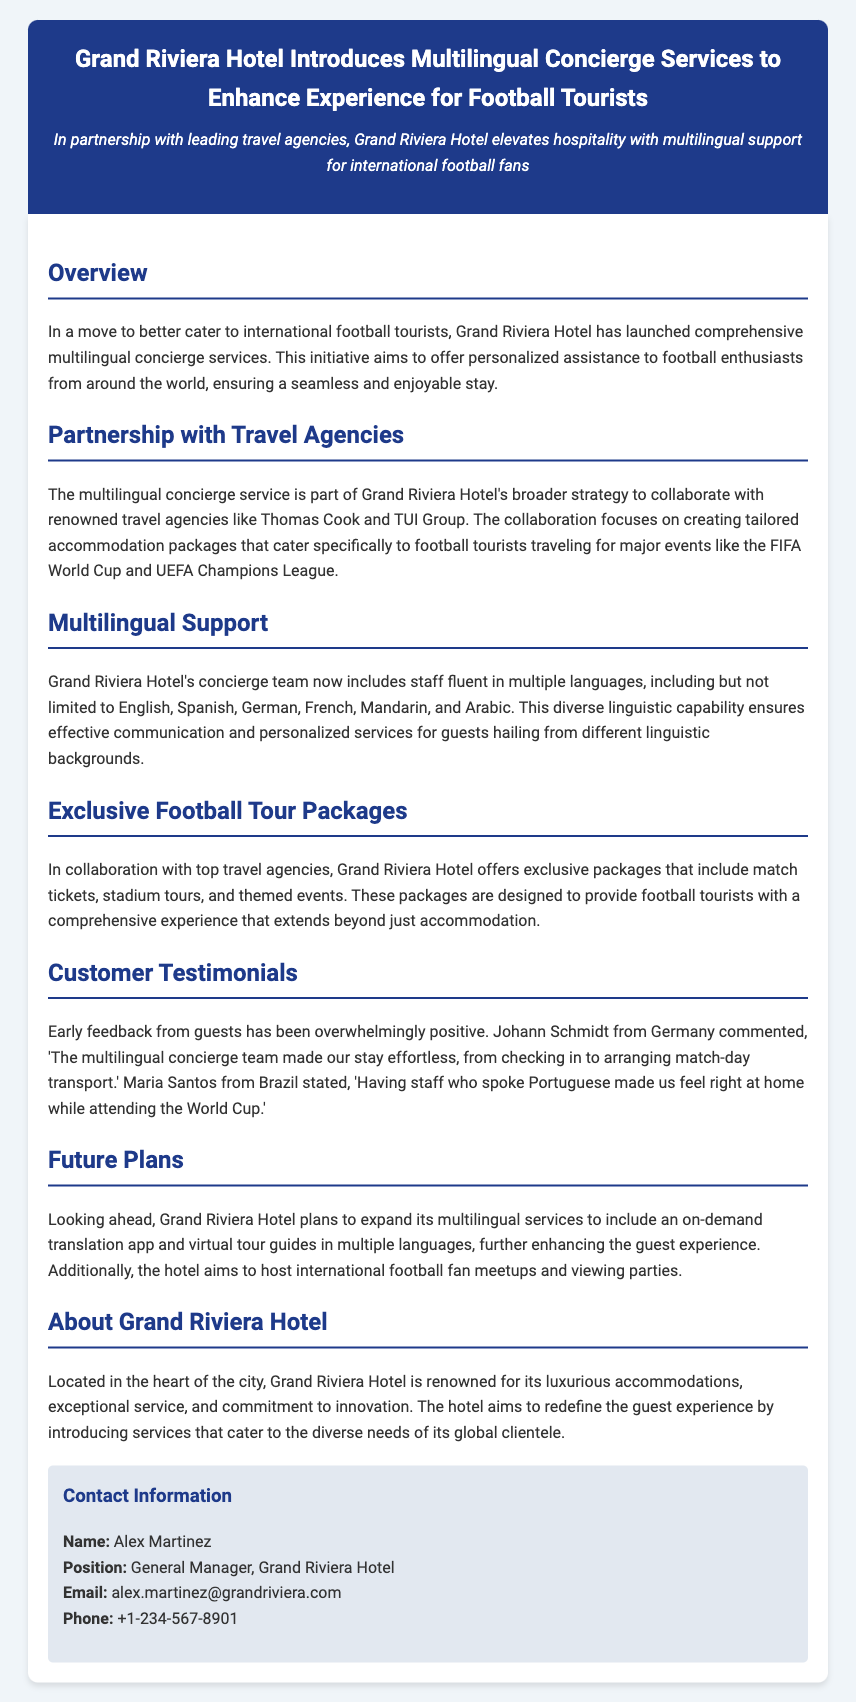What is the name of the hotel introducing concierge services? The document states that Grand Riviera Hotel is introducing the multilingual concierge services.
Answer: Grand Riviera Hotel What languages are included in the multilingual support? The document lists English, Spanish, German, French, Mandarin, and Arabic as languages that staff are fluent in.
Answer: English, Spanish, German, French, Mandarin, and Arabic Which major events are the accommodation packages designed for? The press release specifies the FIFA World Cup and UEFA Champions League as key events for the tailor-made packages.
Answer: FIFA World Cup and UEFA Champions League Who is the General Manager of Grand Riviera Hotel? According to the document, Alex Martinez holds the position of General Manager at the hotel.
Answer: Alex Martinez What type of feedback has the hotel received from guests? The document mentions that early feedback from guests has been overwhelmingly positive in nature.
Answer: Overwhelmingly positive What future plans does Grand Riviera Hotel have for multilingual services? The press release outlines plans to expand services to include an on-demand translation app and virtual tour guides.
Answer: An on-demand translation app and virtual tour guides Which travel agencies has Grand Riviera Hotel partnered with? The document highlights partnerships with renowned travel agencies such as Thomas Cook and TUI Group.
Answer: Thomas Cook and TUI Group 